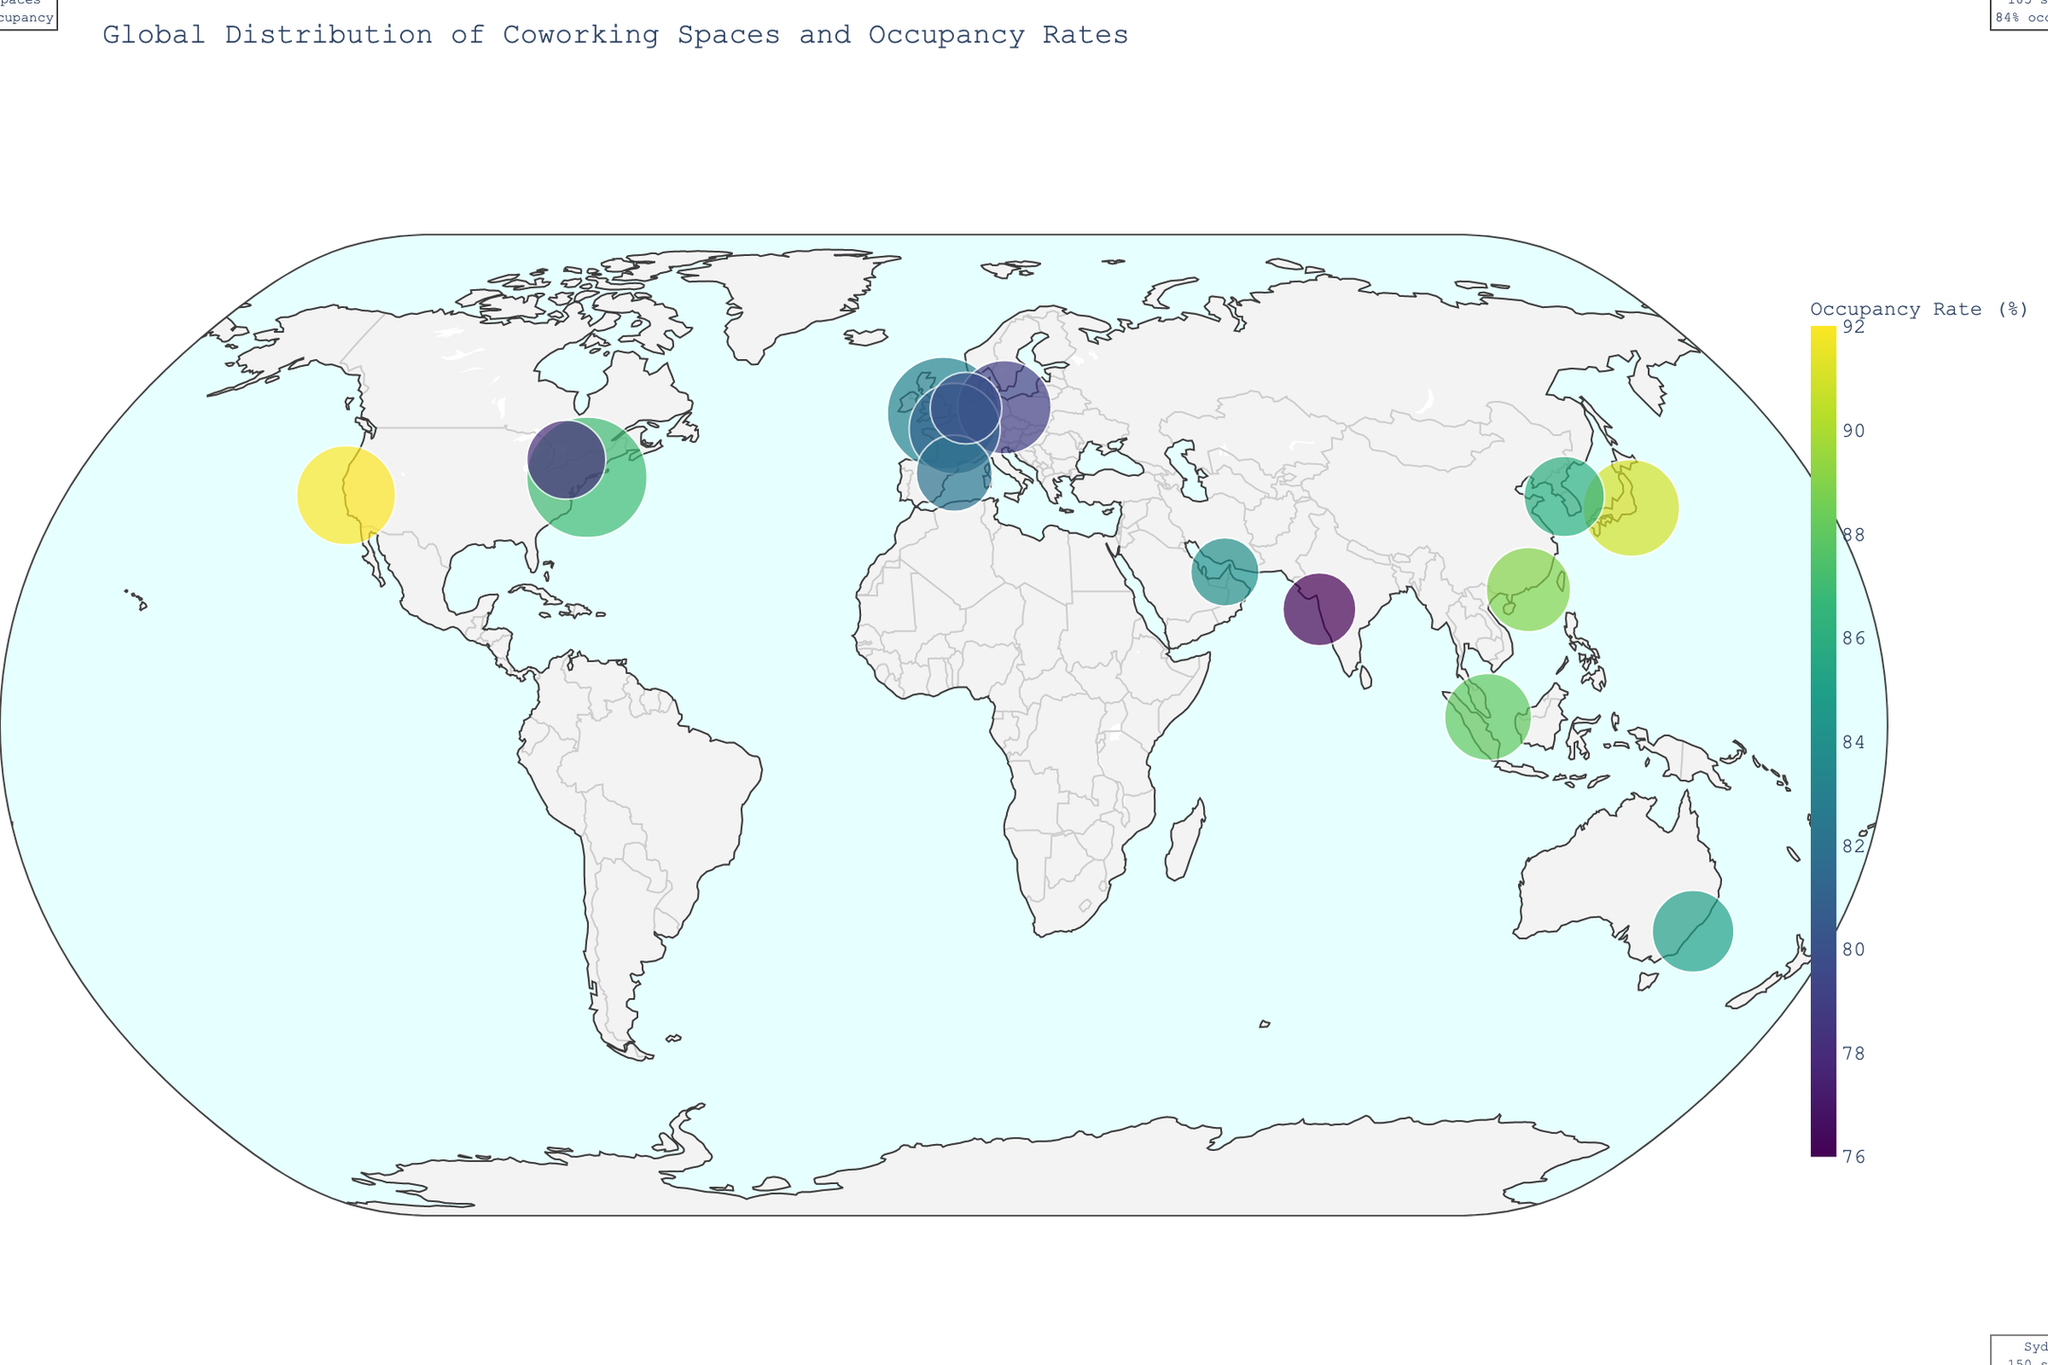What is the total number of coworking spaces in New York? The plot annotates each city with the number of coworking spaces. For New York, the annotation mentions 325 spaces.
Answer: 325 Which city has the highest occupancy rate? The colors on the map indicate the occupancy rates, and the annotation for each city specifies the exact percentage. San Francisco has the highest occupancy rate with 92%.
Answer: San Francisco How many coworking spaces are there globally among the listed cities? We need to sum up the coworking spaces of each city listed in the data. By adding (325+280+210+195+170+220+185+150+140+120+130+115+160+145+105), we get 2,650 spaces.
Answer: 2,650 What is the average occupancy rate of all the listed cities? We calculate the average by summing the occupancy rates of each city (87+83+91+79+88+92+81+85+78+76+82+80+89+86+84) which is 1,301 and dividing by the total number of cities, 15. The average occupancy rate is 86.73 (1301/15).
Answer: 86.73 Which city in Europe has the most coworking spaces? European cities listed in the plot are London, Berlin, Paris, Barcelona, and Amsterdam. According to the plot annotations, London has the most coworking spaces among them with 280 spaces.
Answer: London What is the range of occupancy rates among all the cities? The range is the difference between the highest and lowest occupancy rates. The highest rate is 92% (San Francisco) and the lowest is 76% (Mumbai). Therefore, the range is 92 - 76 = 16.
Answer: 16 Which city has the lowest number of coworking spaces and what is the occupancy rate there? According to the annotations in the plot, Dubai has the lowest number of coworking spaces with 105 spaces and an occupancy rate of 84%.
Answer: Dubai, 84% How does the occupancy rate in Toronto compare to that in Seoul? The plot annotations show that Toronto has an occupancy rate of 78% while Seoul has 86%. Thus, Seoul's rate is higher by 8%.
Answer: Seoul's rate is higher by 8% What is the sum of coworking spaces in Asia? Asian cities listed in the plot are Tokyo, Singapore, Mumbai, Hong Kong, and Seoul. Summing their coworking spaces (210+170+120+160+145), gives us a total of 805 spaces.
Answer: 805 Which continent has the highest combined number of coworking spaces in the cities listed? We need to sum up the coworking spaces by continent. North America (New York, San Francisco, Toronto) has 685; Europe (London, Berlin, Paris, Barcelona, Amsterdam) has 905; Asia (Tokyo, Singapore, Mumbai, Hong Kong, Seoul) has 805; and other regions (Sydney, Dubai) have 255. Europe has the highest combined total of 905 spaces.
Answer: Europe 